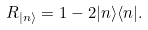Convert formula to latex. <formula><loc_0><loc_0><loc_500><loc_500>R _ { | n \rangle } = 1 - 2 | n \rangle \langle n | .</formula> 